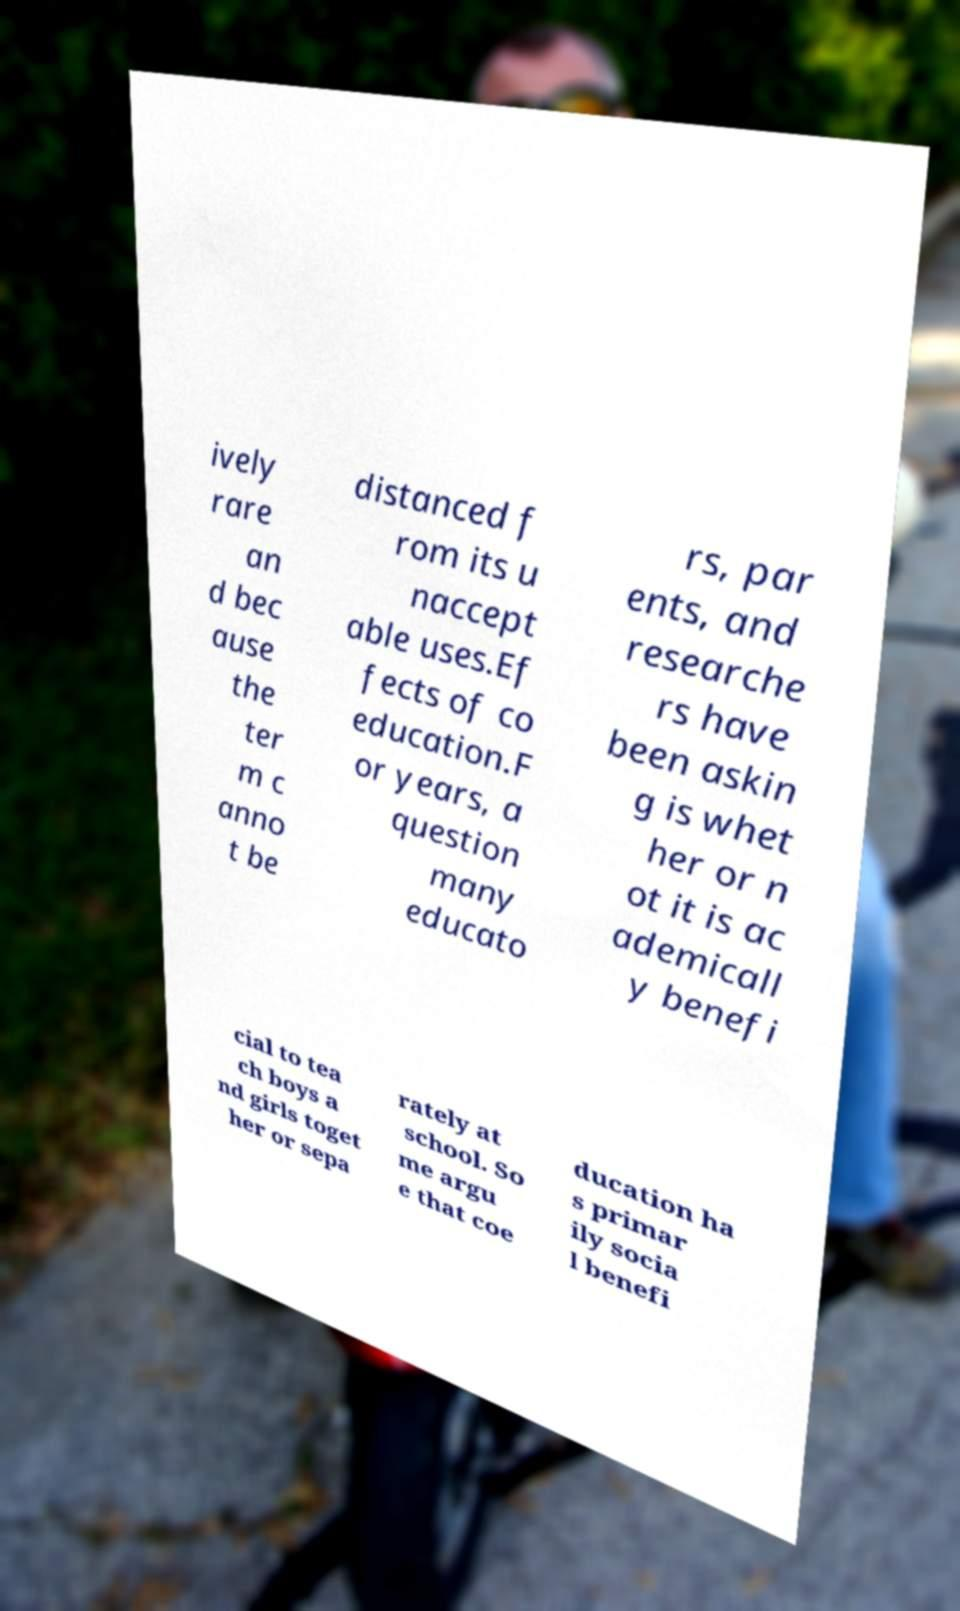Please identify and transcribe the text found in this image. ively rare an d bec ause the ter m c anno t be distanced f rom its u naccept able uses.Ef fects of co education.F or years, a question many educato rs, par ents, and researche rs have been askin g is whet her or n ot it is ac ademicall y benefi cial to tea ch boys a nd girls toget her or sepa rately at school. So me argu e that coe ducation ha s primar ily socia l benefi 